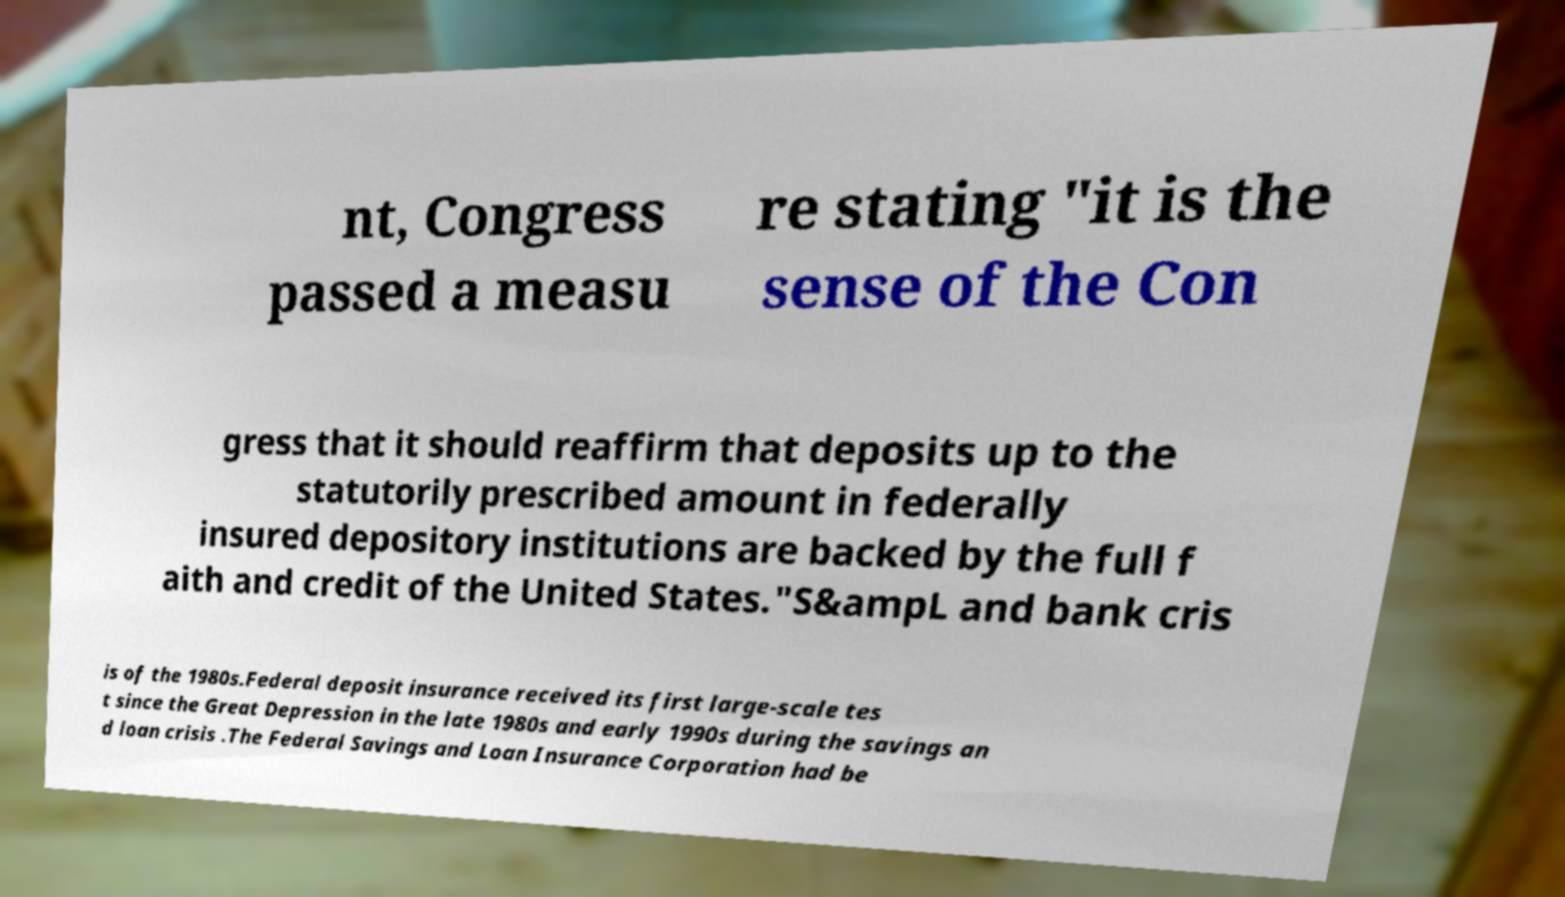I need the written content from this picture converted into text. Can you do that? nt, Congress passed a measu re stating "it is the sense of the Con gress that it should reaffirm that deposits up to the statutorily prescribed amount in federally insured depository institutions are backed by the full f aith and credit of the United States."S&ampL and bank cris is of the 1980s.Federal deposit insurance received its first large-scale tes t since the Great Depression in the late 1980s and early 1990s during the savings an d loan crisis .The Federal Savings and Loan Insurance Corporation had be 